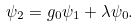<formula> <loc_0><loc_0><loc_500><loc_500>\psi _ { 2 } = g _ { 0 } \psi _ { 1 } + \lambda \psi _ { 0 } .</formula> 